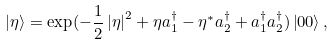<formula> <loc_0><loc_0><loc_500><loc_500>\left | \eta \right \rangle = \exp ( - \frac { 1 } { 2 } \left | \eta \right | ^ { 2 } + \eta a _ { 1 } ^ { \dagger } - \eta ^ { \ast } a _ { 2 } ^ { \dagger } + a _ { 1 } ^ { \dagger } a _ { 2 } ^ { \dagger } ) \left | 0 0 \right \rangle ,</formula> 